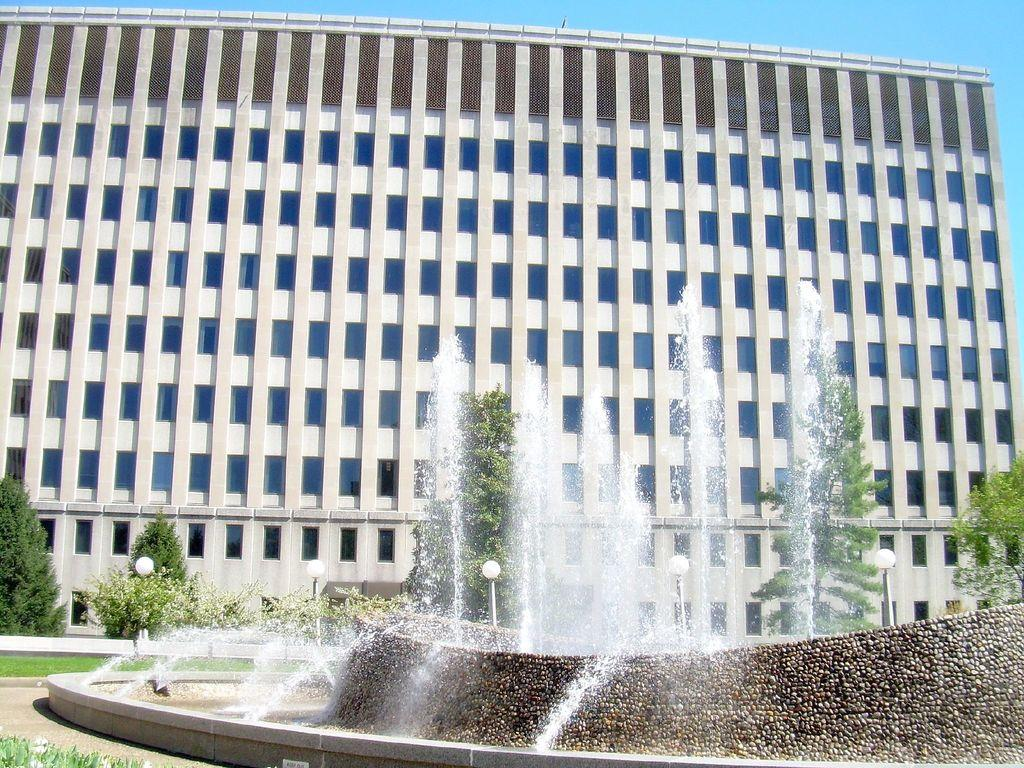What can be seen in the foreground of the image? There are fountains and lamp poles in the foreground of the image. What is visible in the background of the image? There are trees, at least one building, and the sky in the background of the image. How many elements are present in the foreground of the image? There are two elements present in the foreground: fountains and lamp poles. What type of natural environment is visible in the image? The natural environment includes trees in the background. Can you see anyone attempting to frame a rifle in the image? There is no reference to a frame or a rifle in the image, so it is not possible to answer that question. 